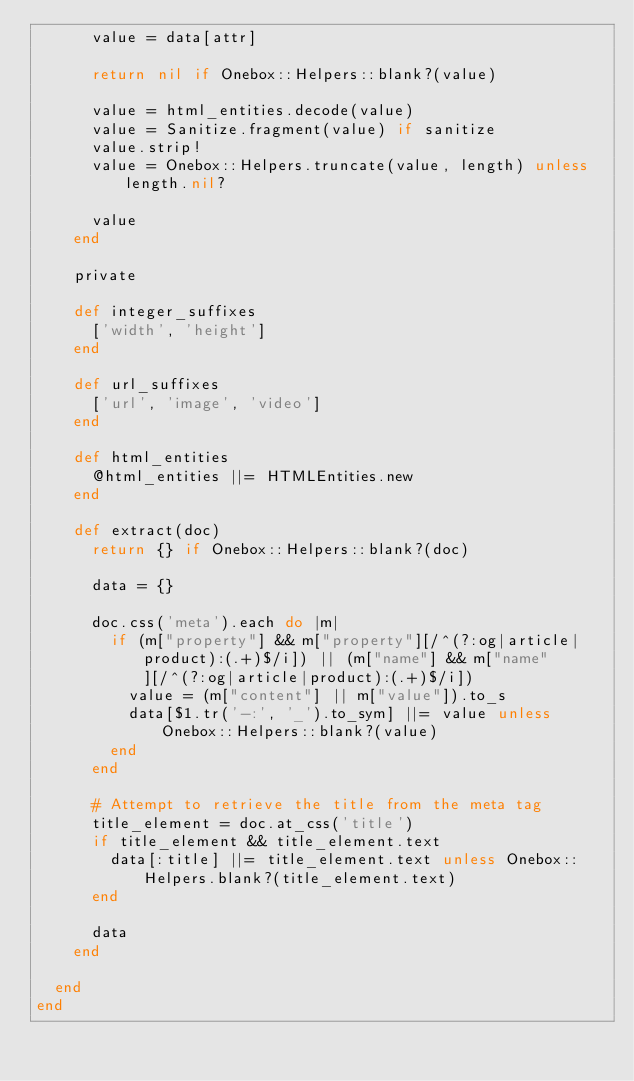Convert code to text. <code><loc_0><loc_0><loc_500><loc_500><_Ruby_>      value = data[attr]

      return nil if Onebox::Helpers::blank?(value)

      value = html_entities.decode(value)
      value = Sanitize.fragment(value) if sanitize
      value.strip!
      value = Onebox::Helpers.truncate(value, length) unless length.nil?

      value
    end

    private

    def integer_suffixes
      ['width', 'height']
    end

    def url_suffixes
      ['url', 'image', 'video']
    end

    def html_entities
      @html_entities ||= HTMLEntities.new
    end

    def extract(doc)
      return {} if Onebox::Helpers::blank?(doc)

      data = {}

      doc.css('meta').each do |m|
        if (m["property"] && m["property"][/^(?:og|article|product):(.+)$/i]) || (m["name"] && m["name"][/^(?:og|article|product):(.+)$/i])
          value = (m["content"] || m["value"]).to_s
          data[$1.tr('-:', '_').to_sym] ||= value unless Onebox::Helpers::blank?(value)
        end
      end

      # Attempt to retrieve the title from the meta tag
      title_element = doc.at_css('title')
      if title_element && title_element.text
        data[:title] ||= title_element.text unless Onebox::Helpers.blank?(title_element.text)
      end

      data
    end

  end
end
</code> 